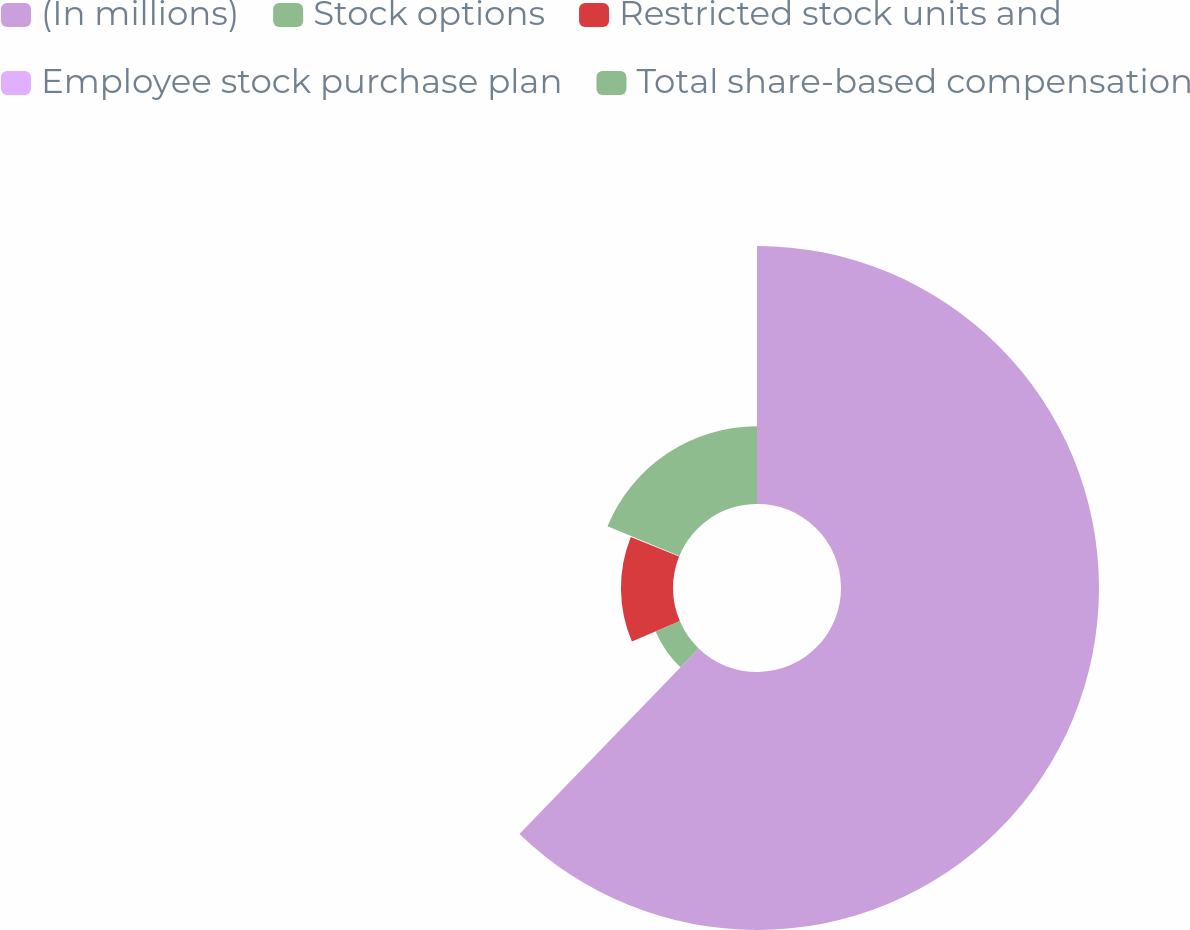Convert chart. <chart><loc_0><loc_0><loc_500><loc_500><pie_chart><fcel>(In millions)<fcel>Stock options<fcel>Restricted stock units and<fcel>Employee stock purchase plan<fcel>Total share-based compensation<nl><fcel>62.22%<fcel>6.34%<fcel>12.55%<fcel>0.13%<fcel>18.76%<nl></chart> 